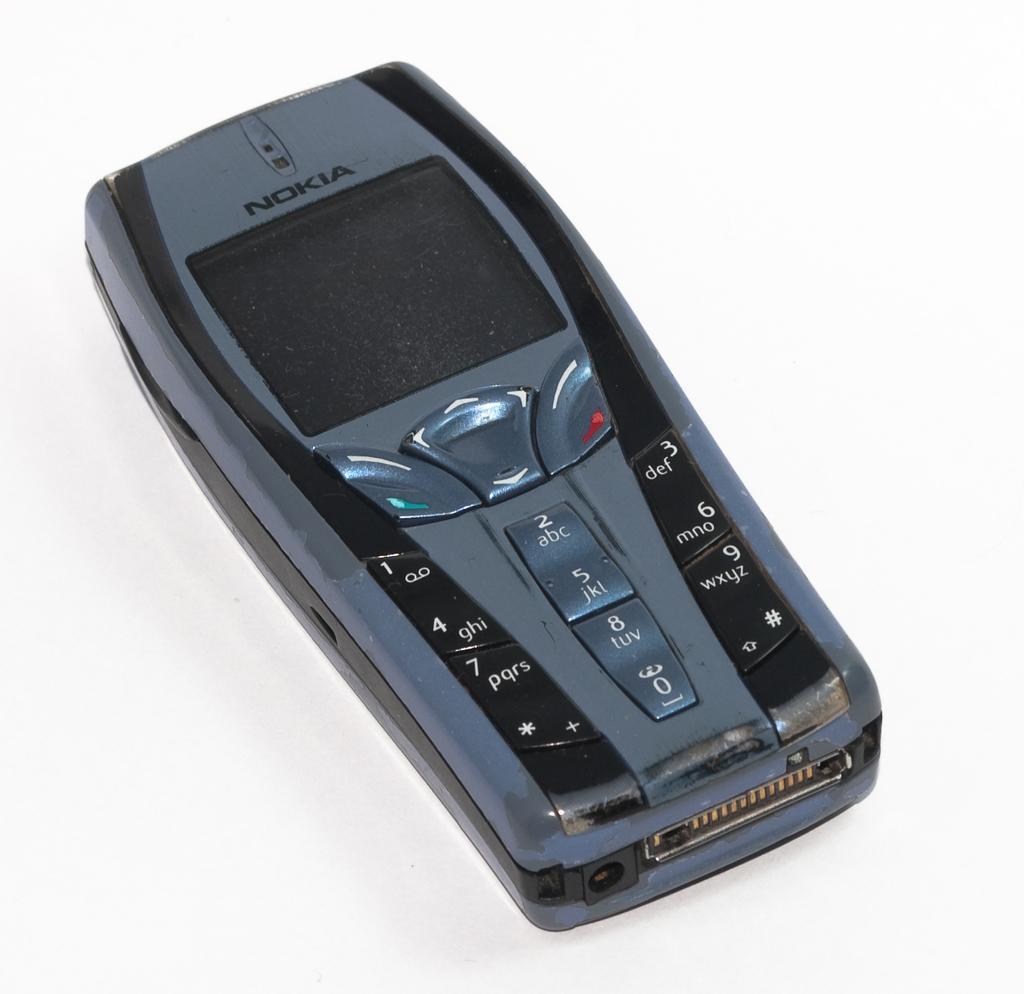How would you summarize this image in a sentence or two? In this picture there is a nokia mobile which has few numbers and some other buttons on it. 